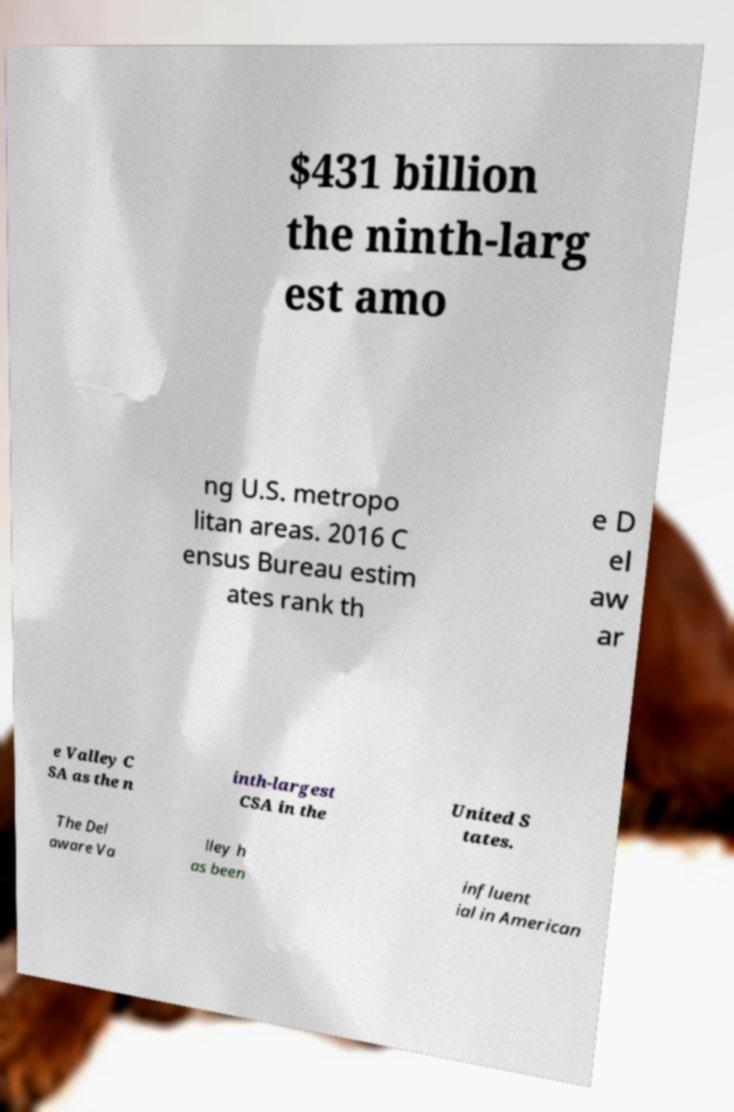What messages or text are displayed in this image? I need them in a readable, typed format. $431 billion the ninth-larg est amo ng U.S. metropo litan areas. 2016 C ensus Bureau estim ates rank th e D el aw ar e Valley C SA as the n inth-largest CSA in the United S tates. The Del aware Va lley h as been influent ial in American 